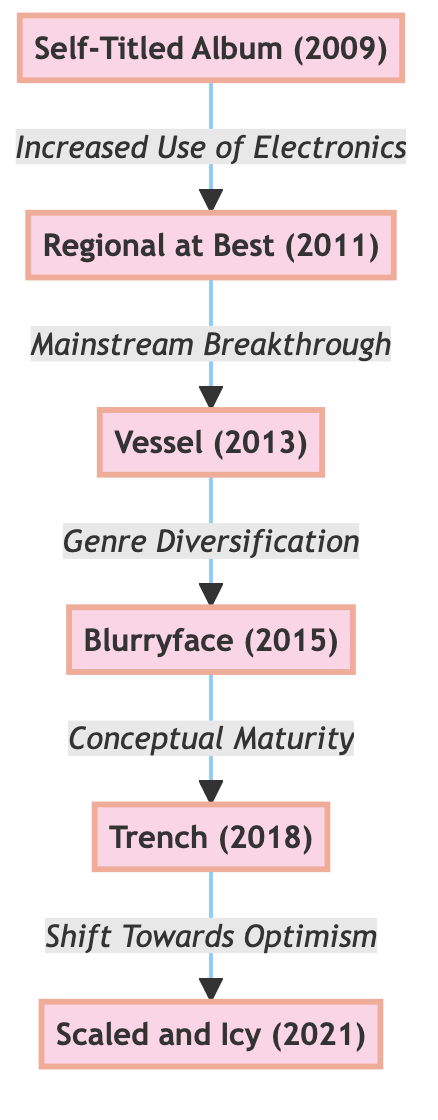What is the first album in the evolution of TØP's music style? The first album listed in the diagram is "Self-Titled Album (2009)," which is where TØP's journey begins.
Answer: Self-Titled Album (2009) How many albums are represented in the diagram? The diagram includes six distinct nodes, each representing an album release throughout TØP's career.
Answer: 6 What transition follows the "Regional at Best (2011)" album? The transition indicated in the diagram from "Regional at Best (2011)" leads into the "Vessel (2013)" album, signified by the label "Mainstream Breakthrough."
Answer: Vessel (2013) Which album is characterized by "Conceptual Maturity"? According to the diagram, "Conceptual Maturity" is associated with the transition from "Blurryface (2015)" to "Trench (2018)."
Answer: Trench (2018) What is the last album in the evolution timeline? The final album depicted in the diagram is "Scaled and Icy (2021)," signifying the endpoint of the evolution shown.
Answer: Scaled and Icy (2021) Identify the musical characteristic that connects "Self-Titled Album (2009)" to "Regional at Best (2011)." The diagram shows that the connection between these two albums is the "Increased Use of Electronics," indicating a shift in their musical style.
Answer: Increased Use of Electronics What label describes the change from "Vessel (2013)" to "Blurryface (2015)"? The diagram indicates that the change is described as "Genre Diversification," which points to an expansion of their musical influences during this period.
Answer: Genre Diversification Which two albums are connected by the label "Shift Towards Optimism"? The label "Shift Towards Optimism" connects the "Trench (2018)" album to "Scaled and Icy (2021)" in the diagram, highlighting a thematic evolution.
Answer: Trench (2018) to Scaled and Icy (2021) Which album is associated with deeper exploration of mental health themes? The "Regional at Best (2011)" album specifically addresses this theme, as indicated in its description within the diagram.
Answer: Regional at Best (2011) 